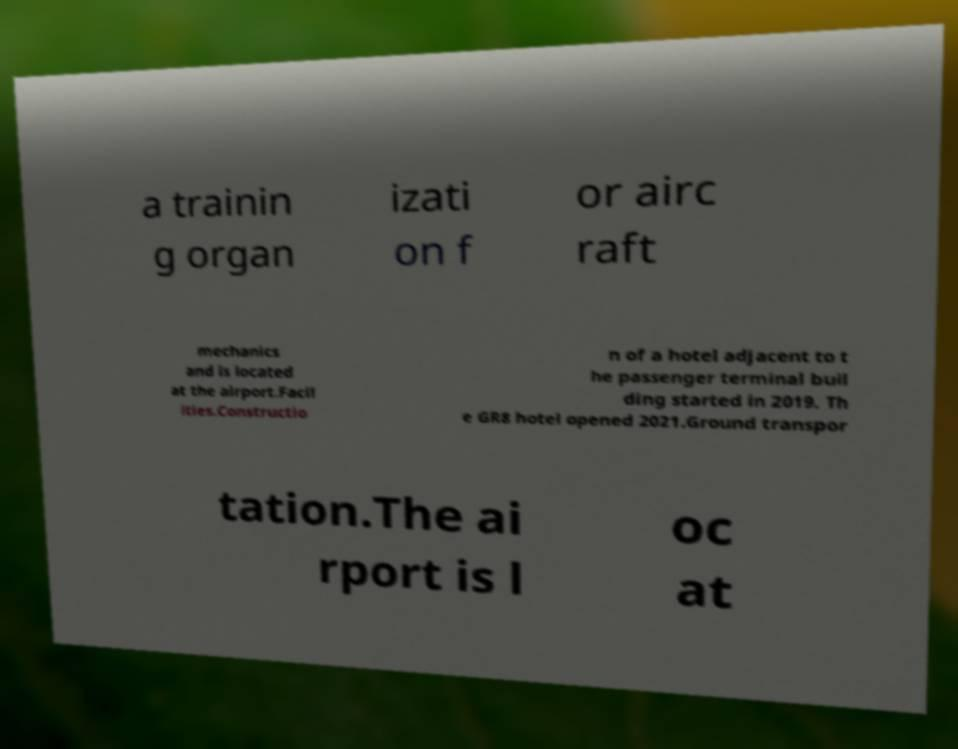Could you extract and type out the text from this image? a trainin g organ izati on f or airc raft mechanics and is located at the airport.Facil ities.Constructio n of a hotel adjacent to t he passenger terminal buil ding started in 2019. Th e GR8 hotel opened 2021.Ground transpor tation.The ai rport is l oc at 